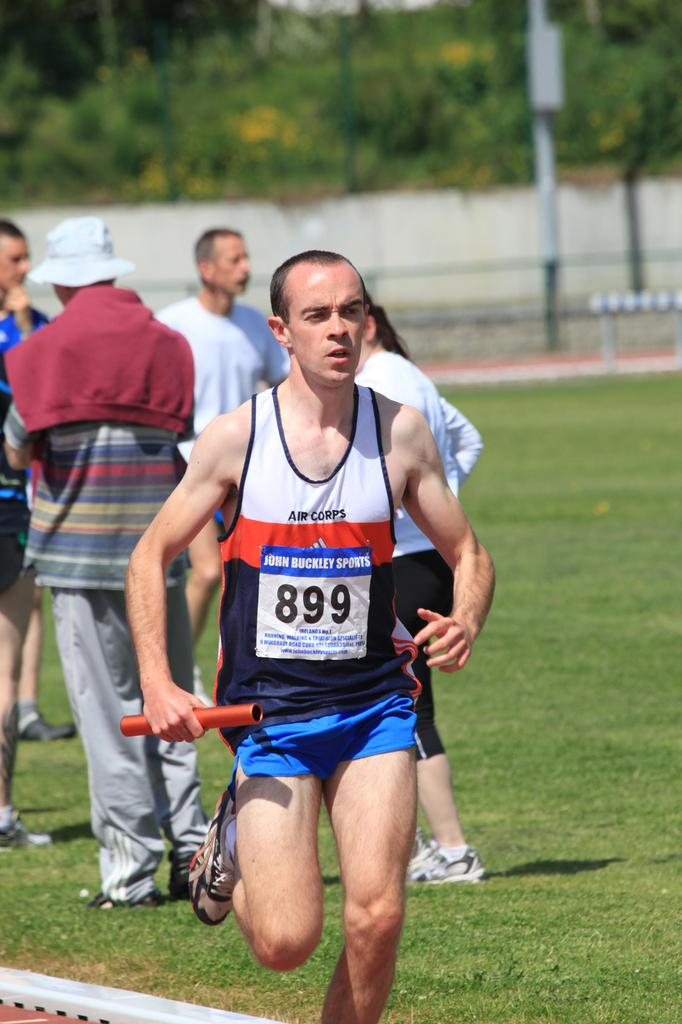<image>
Offer a succinct explanation of the picture presented. A runner bearing the number 899 holds a baton as he passes a group of spectators. 